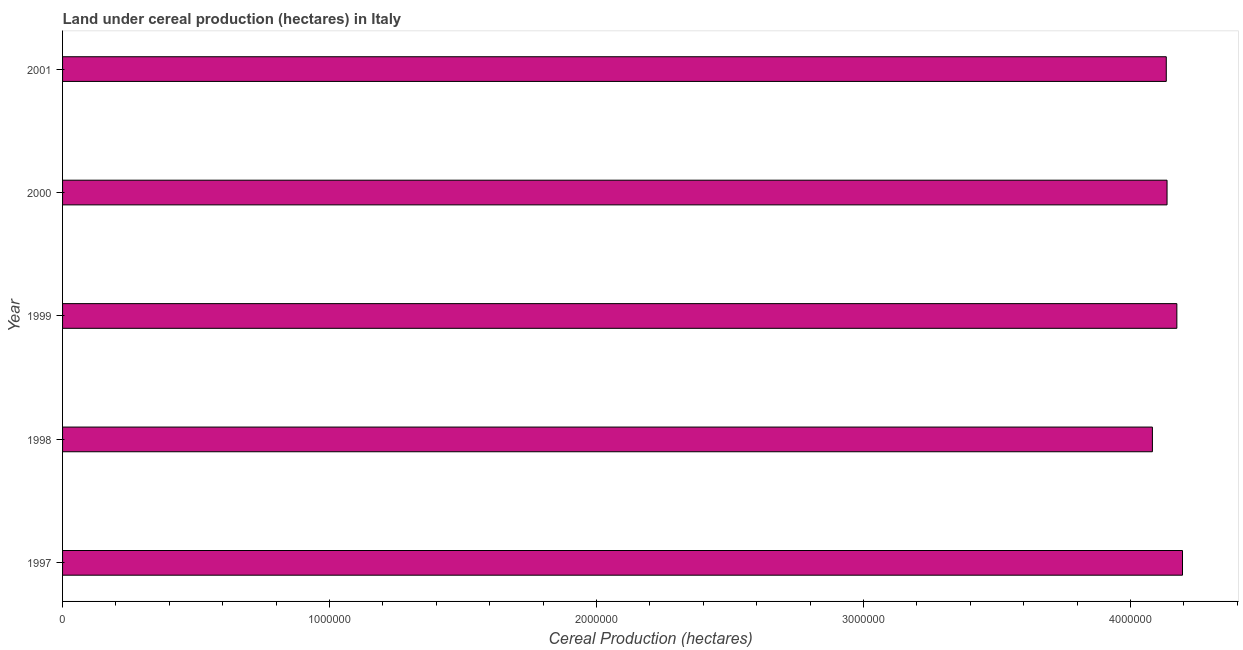Does the graph contain any zero values?
Ensure brevity in your answer.  No. What is the title of the graph?
Ensure brevity in your answer.  Land under cereal production (hectares) in Italy. What is the label or title of the X-axis?
Your response must be concise. Cereal Production (hectares). What is the label or title of the Y-axis?
Make the answer very short. Year. What is the land under cereal production in 1998?
Ensure brevity in your answer.  4.08e+06. Across all years, what is the maximum land under cereal production?
Your answer should be very brief. 4.20e+06. Across all years, what is the minimum land under cereal production?
Offer a terse response. 4.08e+06. What is the sum of the land under cereal production?
Keep it short and to the point. 2.07e+07. What is the difference between the land under cereal production in 1999 and 2001?
Your answer should be compact. 3.97e+04. What is the average land under cereal production per year?
Your answer should be very brief. 4.14e+06. What is the median land under cereal production?
Your answer should be very brief. 4.14e+06. In how many years, is the land under cereal production greater than 1800000 hectares?
Give a very brief answer. 5. Do a majority of the years between 1999 and 2000 (inclusive) have land under cereal production greater than 4000000 hectares?
Offer a very short reply. Yes. What is the ratio of the land under cereal production in 1998 to that in 1999?
Keep it short and to the point. 0.98. Is the land under cereal production in 1999 less than that in 2001?
Offer a very short reply. No. What is the difference between the highest and the second highest land under cereal production?
Your answer should be compact. 2.11e+04. What is the difference between the highest and the lowest land under cereal production?
Offer a very short reply. 1.13e+05. How many bars are there?
Provide a short and direct response. 5. What is the difference between two consecutive major ticks on the X-axis?
Give a very brief answer. 1.00e+06. Are the values on the major ticks of X-axis written in scientific E-notation?
Make the answer very short. No. What is the Cereal Production (hectares) of 1997?
Offer a very short reply. 4.20e+06. What is the Cereal Production (hectares) of 1998?
Offer a very short reply. 4.08e+06. What is the Cereal Production (hectares) of 1999?
Offer a very short reply. 4.17e+06. What is the Cereal Production (hectares) of 2000?
Give a very brief answer. 4.14e+06. What is the Cereal Production (hectares) of 2001?
Your response must be concise. 4.13e+06. What is the difference between the Cereal Production (hectares) in 1997 and 1998?
Offer a very short reply. 1.13e+05. What is the difference between the Cereal Production (hectares) in 1997 and 1999?
Keep it short and to the point. 2.11e+04. What is the difference between the Cereal Production (hectares) in 1997 and 2000?
Provide a short and direct response. 5.78e+04. What is the difference between the Cereal Production (hectares) in 1997 and 2001?
Your answer should be compact. 6.08e+04. What is the difference between the Cereal Production (hectares) in 1998 and 1999?
Ensure brevity in your answer.  -9.16e+04. What is the difference between the Cereal Production (hectares) in 1998 and 2000?
Give a very brief answer. -5.49e+04. What is the difference between the Cereal Production (hectares) in 1998 and 2001?
Ensure brevity in your answer.  -5.19e+04. What is the difference between the Cereal Production (hectares) in 1999 and 2000?
Offer a terse response. 3.68e+04. What is the difference between the Cereal Production (hectares) in 1999 and 2001?
Your answer should be very brief. 3.97e+04. What is the difference between the Cereal Production (hectares) in 2000 and 2001?
Give a very brief answer. 2912. What is the ratio of the Cereal Production (hectares) in 1997 to that in 1998?
Offer a very short reply. 1.03. What is the ratio of the Cereal Production (hectares) in 1997 to that in 2001?
Keep it short and to the point. 1.01. What is the ratio of the Cereal Production (hectares) in 1998 to that in 2000?
Offer a very short reply. 0.99. What is the ratio of the Cereal Production (hectares) in 2000 to that in 2001?
Provide a short and direct response. 1. 